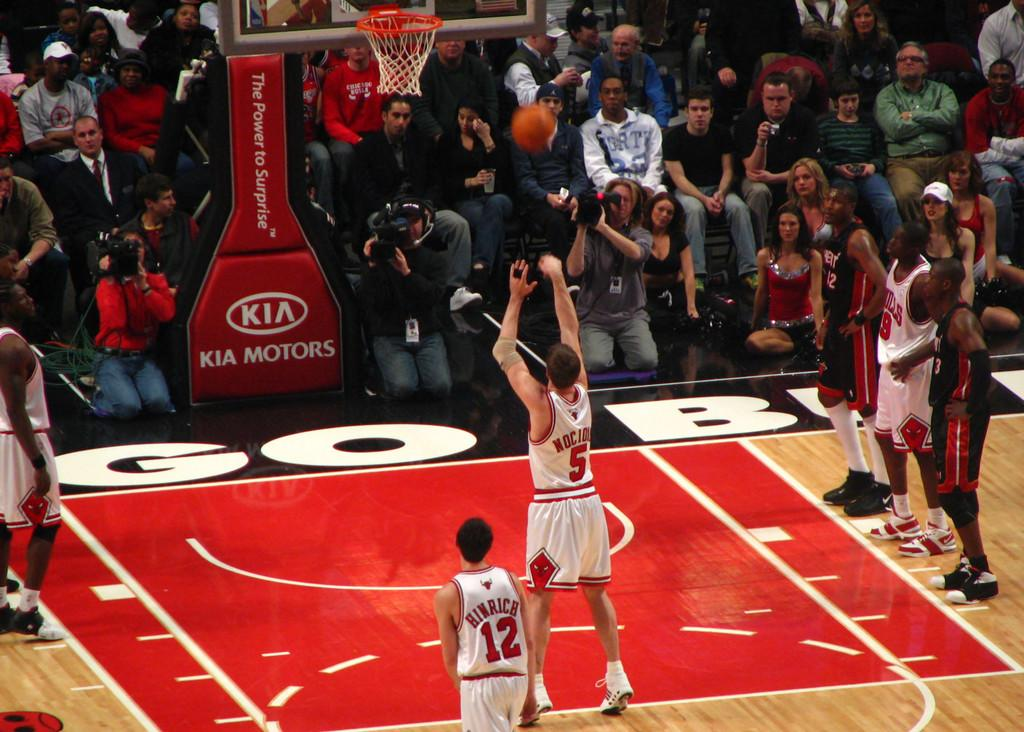<image>
Render a clear and concise summary of the photo. Player number 5 shoots the ball into the basket on a Kia Motors basketball hoop 